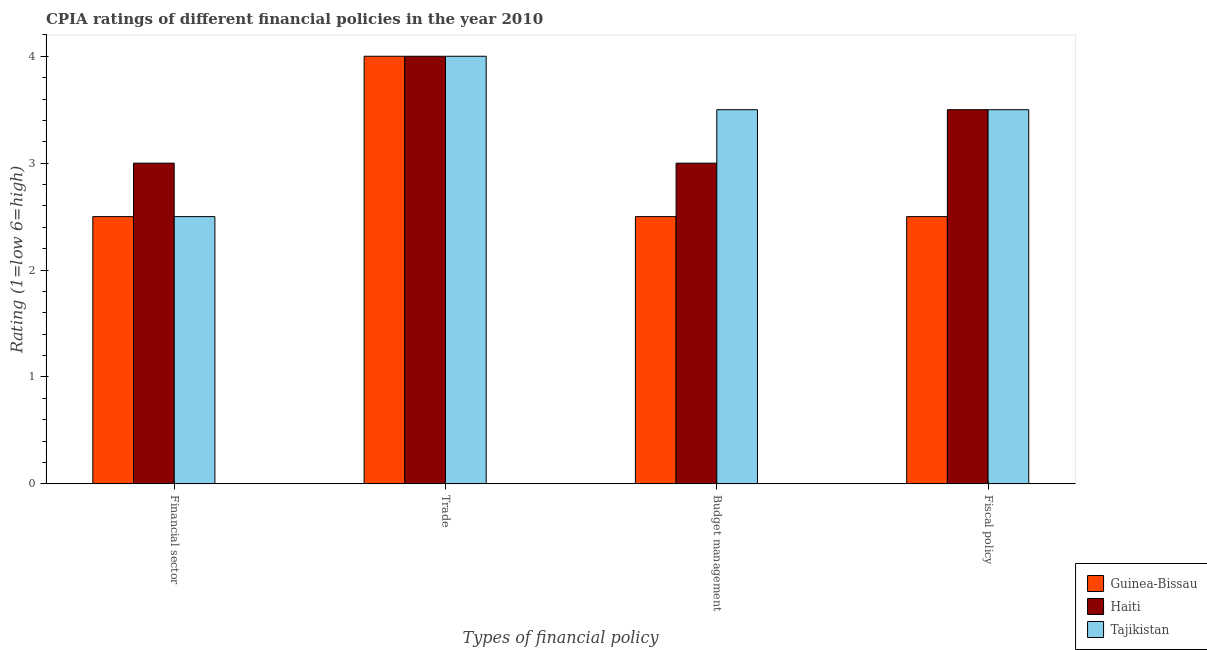How many bars are there on the 4th tick from the left?
Offer a terse response. 3. What is the label of the 4th group of bars from the left?
Your answer should be very brief. Fiscal policy. Across all countries, what is the minimum cpia rating of financial sector?
Ensure brevity in your answer.  2.5. In which country was the cpia rating of trade maximum?
Provide a succinct answer. Guinea-Bissau. In which country was the cpia rating of fiscal policy minimum?
Ensure brevity in your answer.  Guinea-Bissau. What is the difference between the cpia rating of financial sector in Tajikistan and that in Guinea-Bissau?
Ensure brevity in your answer.  0. What is the average cpia rating of budget management per country?
Give a very brief answer. 3. In how many countries, is the cpia rating of trade greater than 4 ?
Your answer should be compact. 0. What is the ratio of the cpia rating of budget management in Tajikistan to that in Guinea-Bissau?
Your answer should be compact. 1.4. Is the sum of the cpia rating of fiscal policy in Tajikistan and Haiti greater than the maximum cpia rating of trade across all countries?
Make the answer very short. Yes. What does the 3rd bar from the left in Fiscal policy represents?
Make the answer very short. Tajikistan. What does the 3rd bar from the right in Budget management represents?
Offer a terse response. Guinea-Bissau. Is it the case that in every country, the sum of the cpia rating of financial sector and cpia rating of trade is greater than the cpia rating of budget management?
Your answer should be very brief. Yes. Does the graph contain any zero values?
Your answer should be compact. No. Does the graph contain grids?
Your response must be concise. No. How many legend labels are there?
Your response must be concise. 3. How are the legend labels stacked?
Your answer should be very brief. Vertical. What is the title of the graph?
Provide a short and direct response. CPIA ratings of different financial policies in the year 2010. Does "Yemen, Rep." appear as one of the legend labels in the graph?
Make the answer very short. No. What is the label or title of the X-axis?
Your response must be concise. Types of financial policy. What is the Rating (1=low 6=high) in Haiti in Financial sector?
Keep it short and to the point. 3. What is the Rating (1=low 6=high) in Haiti in Trade?
Ensure brevity in your answer.  4. What is the Rating (1=low 6=high) of Guinea-Bissau in Budget management?
Provide a short and direct response. 2.5. What is the Rating (1=low 6=high) in Tajikistan in Budget management?
Offer a very short reply. 3.5. What is the Rating (1=low 6=high) in Guinea-Bissau in Fiscal policy?
Your answer should be compact. 2.5. Across all Types of financial policy, what is the minimum Rating (1=low 6=high) in Haiti?
Your answer should be compact. 3. What is the total Rating (1=low 6=high) of Haiti in the graph?
Ensure brevity in your answer.  13.5. What is the difference between the Rating (1=low 6=high) of Haiti in Financial sector and that in Trade?
Offer a terse response. -1. What is the difference between the Rating (1=low 6=high) in Haiti in Financial sector and that in Fiscal policy?
Provide a succinct answer. -0.5. What is the difference between the Rating (1=low 6=high) of Tajikistan in Financial sector and that in Fiscal policy?
Keep it short and to the point. -1. What is the difference between the Rating (1=low 6=high) of Guinea-Bissau in Trade and that in Budget management?
Provide a succinct answer. 1.5. What is the difference between the Rating (1=low 6=high) of Haiti in Trade and that in Budget management?
Ensure brevity in your answer.  1. What is the difference between the Rating (1=low 6=high) in Guinea-Bissau in Trade and that in Fiscal policy?
Keep it short and to the point. 1.5. What is the difference between the Rating (1=low 6=high) of Guinea-Bissau in Budget management and that in Fiscal policy?
Your answer should be compact. 0. What is the difference between the Rating (1=low 6=high) of Haiti in Budget management and that in Fiscal policy?
Give a very brief answer. -0.5. What is the difference between the Rating (1=low 6=high) in Guinea-Bissau in Financial sector and the Rating (1=low 6=high) in Haiti in Trade?
Provide a short and direct response. -1.5. What is the difference between the Rating (1=low 6=high) in Guinea-Bissau in Financial sector and the Rating (1=low 6=high) in Tajikistan in Trade?
Your response must be concise. -1.5. What is the difference between the Rating (1=low 6=high) of Haiti in Financial sector and the Rating (1=low 6=high) of Tajikistan in Trade?
Keep it short and to the point. -1. What is the difference between the Rating (1=low 6=high) in Guinea-Bissau in Financial sector and the Rating (1=low 6=high) in Haiti in Budget management?
Offer a terse response. -0.5. What is the difference between the Rating (1=low 6=high) of Haiti in Financial sector and the Rating (1=low 6=high) of Tajikistan in Budget management?
Keep it short and to the point. -0.5. What is the difference between the Rating (1=low 6=high) in Haiti in Financial sector and the Rating (1=low 6=high) in Tajikistan in Fiscal policy?
Provide a succinct answer. -0.5. What is the difference between the Rating (1=low 6=high) in Guinea-Bissau in Trade and the Rating (1=low 6=high) in Tajikistan in Budget management?
Your answer should be compact. 0.5. What is the difference between the Rating (1=low 6=high) of Guinea-Bissau in Trade and the Rating (1=low 6=high) of Haiti in Fiscal policy?
Ensure brevity in your answer.  0.5. What is the difference between the Rating (1=low 6=high) of Guinea-Bissau in Budget management and the Rating (1=low 6=high) of Haiti in Fiscal policy?
Provide a succinct answer. -1. What is the difference between the Rating (1=low 6=high) in Guinea-Bissau in Budget management and the Rating (1=low 6=high) in Tajikistan in Fiscal policy?
Your answer should be very brief. -1. What is the difference between the Rating (1=low 6=high) in Haiti in Budget management and the Rating (1=low 6=high) in Tajikistan in Fiscal policy?
Provide a succinct answer. -0.5. What is the average Rating (1=low 6=high) of Guinea-Bissau per Types of financial policy?
Your answer should be very brief. 2.88. What is the average Rating (1=low 6=high) in Haiti per Types of financial policy?
Your answer should be compact. 3.38. What is the average Rating (1=low 6=high) in Tajikistan per Types of financial policy?
Offer a very short reply. 3.38. What is the difference between the Rating (1=low 6=high) in Guinea-Bissau and Rating (1=low 6=high) in Haiti in Financial sector?
Keep it short and to the point. -0.5. What is the difference between the Rating (1=low 6=high) in Guinea-Bissau and Rating (1=low 6=high) in Tajikistan in Financial sector?
Your answer should be compact. 0. What is the difference between the Rating (1=low 6=high) in Haiti and Rating (1=low 6=high) in Tajikistan in Financial sector?
Make the answer very short. 0.5. What is the difference between the Rating (1=low 6=high) in Guinea-Bissau and Rating (1=low 6=high) in Haiti in Trade?
Provide a short and direct response. 0. What is the difference between the Rating (1=low 6=high) in Guinea-Bissau and Rating (1=low 6=high) in Tajikistan in Trade?
Offer a very short reply. 0. What is the difference between the Rating (1=low 6=high) in Haiti and Rating (1=low 6=high) in Tajikistan in Trade?
Keep it short and to the point. 0. What is the difference between the Rating (1=low 6=high) in Guinea-Bissau and Rating (1=low 6=high) in Haiti in Budget management?
Your answer should be very brief. -0.5. What is the difference between the Rating (1=low 6=high) of Haiti and Rating (1=low 6=high) of Tajikistan in Budget management?
Give a very brief answer. -0.5. What is the difference between the Rating (1=low 6=high) of Guinea-Bissau and Rating (1=low 6=high) of Tajikistan in Fiscal policy?
Your answer should be compact. -1. What is the ratio of the Rating (1=low 6=high) of Haiti in Financial sector to that in Trade?
Provide a short and direct response. 0.75. What is the ratio of the Rating (1=low 6=high) of Tajikistan in Financial sector to that in Trade?
Your answer should be compact. 0.62. What is the ratio of the Rating (1=low 6=high) of Tajikistan in Financial sector to that in Budget management?
Ensure brevity in your answer.  0.71. What is the ratio of the Rating (1=low 6=high) in Tajikistan in Trade to that in Fiscal policy?
Your answer should be compact. 1.14. What is the ratio of the Rating (1=low 6=high) of Haiti in Budget management to that in Fiscal policy?
Offer a terse response. 0.86. What is the ratio of the Rating (1=low 6=high) of Tajikistan in Budget management to that in Fiscal policy?
Your answer should be very brief. 1. What is the difference between the highest and the second highest Rating (1=low 6=high) in Haiti?
Your answer should be compact. 0.5. What is the difference between the highest and the lowest Rating (1=low 6=high) in Guinea-Bissau?
Your answer should be compact. 1.5. What is the difference between the highest and the lowest Rating (1=low 6=high) in Haiti?
Your answer should be compact. 1. What is the difference between the highest and the lowest Rating (1=low 6=high) of Tajikistan?
Provide a short and direct response. 1.5. 